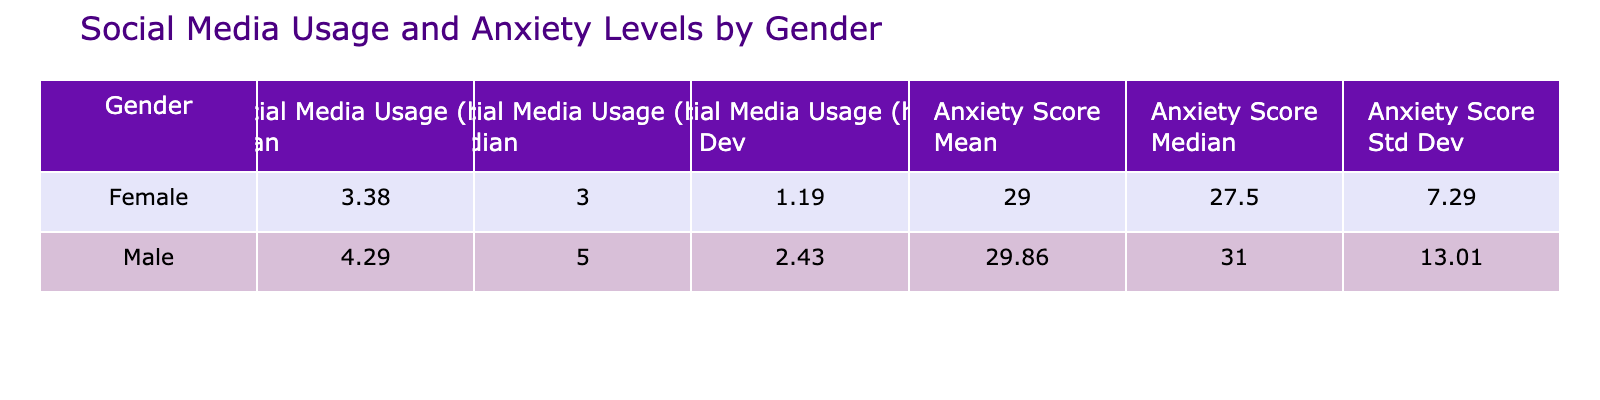What is the mean Social Media Usage for females? To find the mean Social Media Usage for females, we look at the table and identify the mean value listed under the female category. The mean for females is 3.00 hours.
Answer: 3.00 What is the standard deviation of Anxiety Level for males? The table shows the standard deviation for Anxiety Level under the male category. The value is 11.41.
Answer: 11.41 Is the mean Anxiety Level score higher for females than for males? We compare the mean Anxiety Level score for females (30.40) and males (30.71) as shown in the table. Since 30.40 is less than 30.71, the statement is false.
Answer: No What is the difference between the median Anxiety Level scores of males and females? The median Anxiety Level scores for males and females are found in the table: females have a median of 32.50, and males have a median of 30.50. The difference is 32.50 - 30.50 = 2.00.
Answer: 2.00 What is the average Social Media Usage for all adolescents? To calculate the average Social Media Usage, we sum the daily hours (3 + 5 + 2 + 6 + 4 + 1 + 5 + 7 + 2 + 3 + 4 + 3 + 6 + 5 + 1) and divide by the total number of adolescents (15). The sum is 50, so the average is 50 / 15 ≈ 3.33 hours.
Answer: 3.33 Do adolescents with higher social media usage tend to have higher anxiety levels? A comparison of the mean Anxiety Levels and Social Media Usage in the table indicates higher social media usage correlates with higher average anxiety scores. Both male and female categories reflect this trend.
Answer: Yes What is the median value of Social Media Usage for females? The median Social Media Usage for females can be found in the statistics for females in the table, where it is noted as 3.00 hours.
Answer: 3.00 Which gender has a higher mean score for anxiety levels, and what is the score? By examining the mean Anxiety Level scores in the table, males have a mean score of 30.71, while females have a mean score of 30.40. Since 30.71 is greater, males have the higher score.
Answer: Males, 30.71 Calculate the overall standard deviation of Anxiety Levels for adolescents. The overall standard deviation can be found in the table, calculated as 11.09. It encompasses all adolescents’ Anxiety Level data combined.
Answer: 11.09 